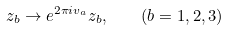Convert formula to latex. <formula><loc_0><loc_0><loc_500><loc_500>z _ { b } \rightarrow e ^ { 2 \pi i v _ { a } } z _ { b } , \quad ( b = 1 , 2 , 3 )</formula> 